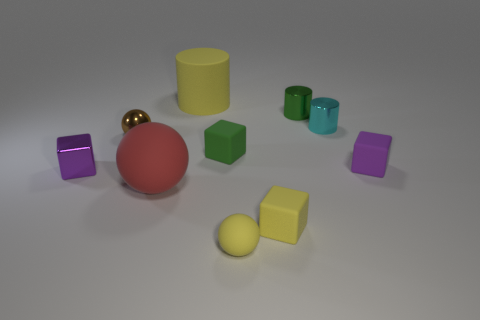Which is the largest object, and what color is it? The largest object appears to be the red sphere at the center. Its size seems significant compared to the other objects in the image. 